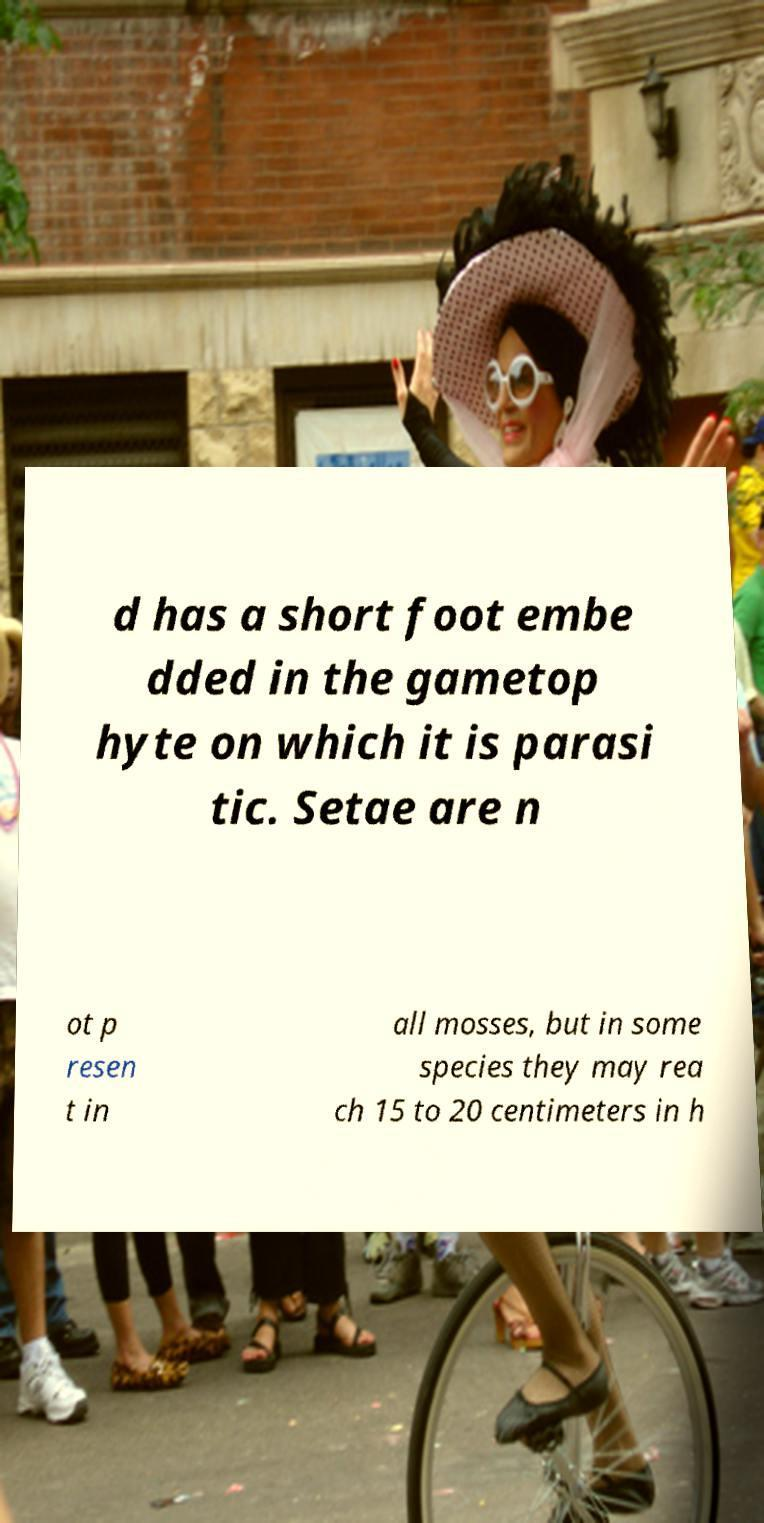What messages or text are displayed in this image? I need them in a readable, typed format. d has a short foot embe dded in the gametop hyte on which it is parasi tic. Setae are n ot p resen t in all mosses, but in some species they may rea ch 15 to 20 centimeters in h 